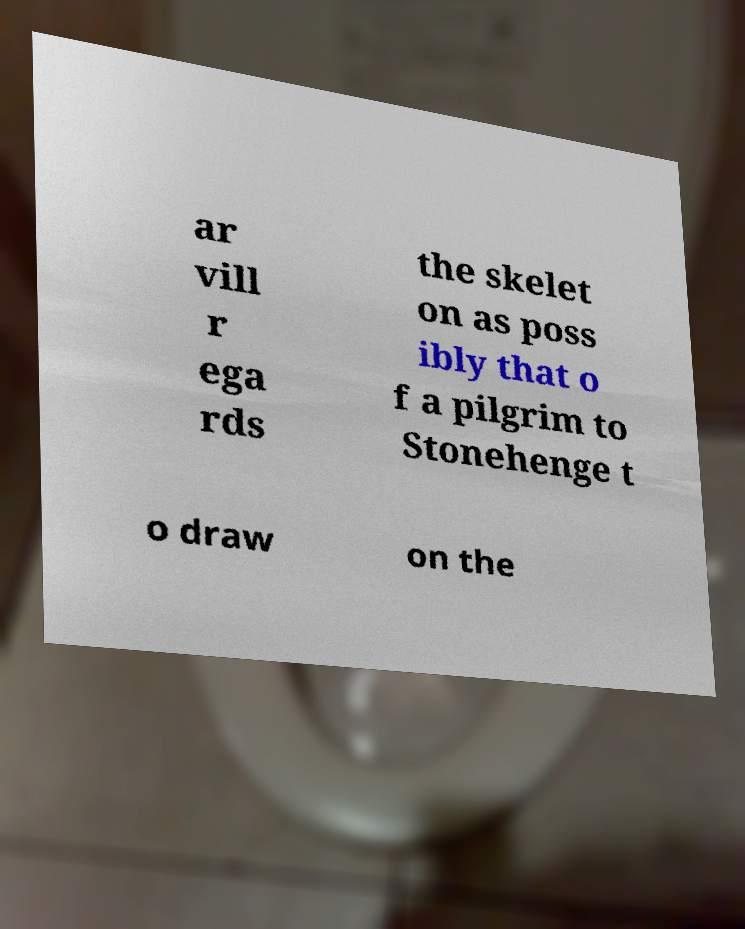For documentation purposes, I need the text within this image transcribed. Could you provide that? ar vill r ega rds the skelet on as poss ibly that o f a pilgrim to Stonehenge t o draw on the 